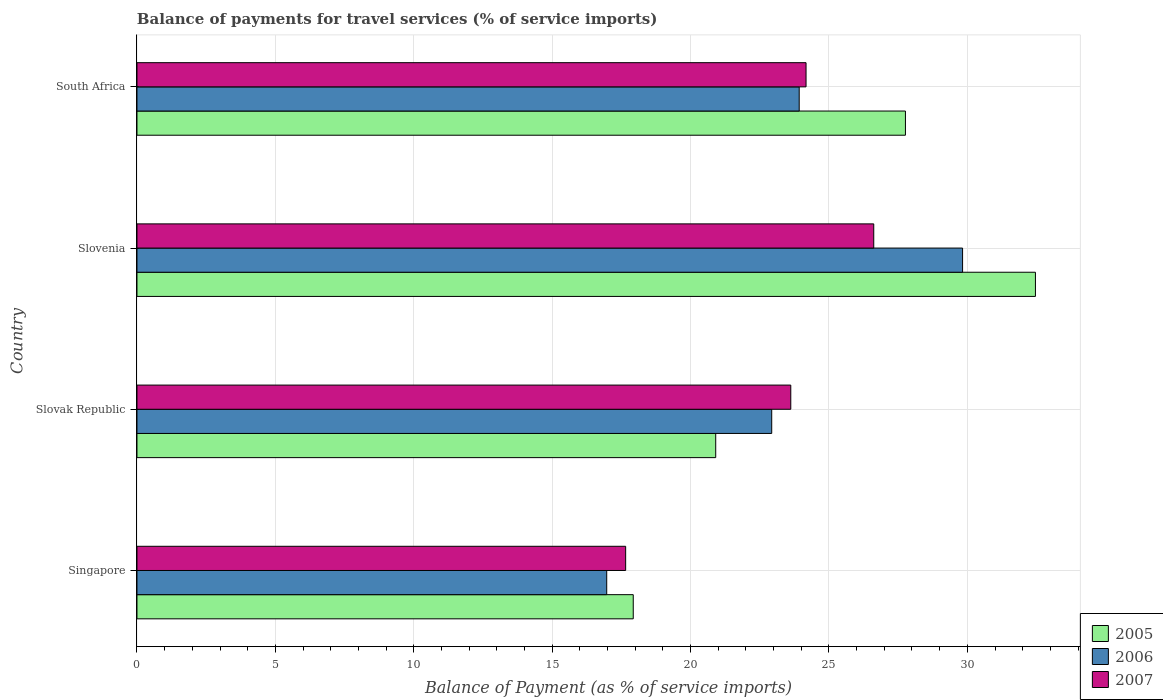How many different coloured bars are there?
Offer a terse response. 3. How many groups of bars are there?
Your answer should be very brief. 4. What is the label of the 4th group of bars from the top?
Your answer should be compact. Singapore. What is the balance of payments for travel services in 2007 in Slovak Republic?
Make the answer very short. 23.62. Across all countries, what is the maximum balance of payments for travel services in 2006?
Offer a terse response. 29.83. Across all countries, what is the minimum balance of payments for travel services in 2005?
Give a very brief answer. 17.93. In which country was the balance of payments for travel services in 2007 maximum?
Give a very brief answer. Slovenia. In which country was the balance of payments for travel services in 2005 minimum?
Ensure brevity in your answer.  Singapore. What is the total balance of payments for travel services in 2007 in the graph?
Your answer should be compact. 92.07. What is the difference between the balance of payments for travel services in 2006 in Singapore and that in Slovak Republic?
Give a very brief answer. -5.96. What is the difference between the balance of payments for travel services in 2007 in Slovak Republic and the balance of payments for travel services in 2005 in Slovenia?
Your answer should be compact. -8.84. What is the average balance of payments for travel services in 2007 per country?
Your answer should be compact. 23.02. What is the difference between the balance of payments for travel services in 2007 and balance of payments for travel services in 2005 in Slovak Republic?
Keep it short and to the point. 2.71. In how many countries, is the balance of payments for travel services in 2007 greater than 28 %?
Your answer should be very brief. 0. What is the ratio of the balance of payments for travel services in 2007 in Singapore to that in Slovak Republic?
Your response must be concise. 0.75. Is the balance of payments for travel services in 2005 in Slovak Republic less than that in Slovenia?
Give a very brief answer. Yes. Is the difference between the balance of payments for travel services in 2007 in Singapore and South Africa greater than the difference between the balance of payments for travel services in 2005 in Singapore and South Africa?
Ensure brevity in your answer.  Yes. What is the difference between the highest and the second highest balance of payments for travel services in 2005?
Keep it short and to the point. 4.7. What is the difference between the highest and the lowest balance of payments for travel services in 2007?
Make the answer very short. 8.96. Is the sum of the balance of payments for travel services in 2006 in Singapore and Slovak Republic greater than the maximum balance of payments for travel services in 2007 across all countries?
Make the answer very short. Yes. What does the 3rd bar from the bottom in Slovak Republic represents?
Give a very brief answer. 2007. Is it the case that in every country, the sum of the balance of payments for travel services in 2006 and balance of payments for travel services in 2007 is greater than the balance of payments for travel services in 2005?
Provide a succinct answer. Yes. What is the difference between two consecutive major ticks on the X-axis?
Ensure brevity in your answer.  5. Does the graph contain grids?
Offer a very short reply. Yes. Where does the legend appear in the graph?
Provide a succinct answer. Bottom right. How are the legend labels stacked?
Ensure brevity in your answer.  Vertical. What is the title of the graph?
Ensure brevity in your answer.  Balance of payments for travel services (% of service imports). What is the label or title of the X-axis?
Your response must be concise. Balance of Payment (as % of service imports). What is the label or title of the Y-axis?
Ensure brevity in your answer.  Country. What is the Balance of Payment (as % of service imports) in 2005 in Singapore?
Your answer should be very brief. 17.93. What is the Balance of Payment (as % of service imports) in 2006 in Singapore?
Your response must be concise. 16.97. What is the Balance of Payment (as % of service imports) in 2007 in Singapore?
Provide a short and direct response. 17.66. What is the Balance of Payment (as % of service imports) of 2005 in Slovak Republic?
Ensure brevity in your answer.  20.91. What is the Balance of Payment (as % of service imports) of 2006 in Slovak Republic?
Your answer should be compact. 22.93. What is the Balance of Payment (as % of service imports) in 2007 in Slovak Republic?
Your response must be concise. 23.62. What is the Balance of Payment (as % of service imports) of 2005 in Slovenia?
Offer a terse response. 32.46. What is the Balance of Payment (as % of service imports) of 2006 in Slovenia?
Provide a succinct answer. 29.83. What is the Balance of Payment (as % of service imports) in 2007 in Slovenia?
Make the answer very short. 26.62. What is the Balance of Payment (as % of service imports) of 2005 in South Africa?
Provide a short and direct response. 27.76. What is the Balance of Payment (as % of service imports) in 2006 in South Africa?
Keep it short and to the point. 23.93. What is the Balance of Payment (as % of service imports) in 2007 in South Africa?
Ensure brevity in your answer.  24.17. Across all countries, what is the maximum Balance of Payment (as % of service imports) of 2005?
Make the answer very short. 32.46. Across all countries, what is the maximum Balance of Payment (as % of service imports) of 2006?
Keep it short and to the point. 29.83. Across all countries, what is the maximum Balance of Payment (as % of service imports) in 2007?
Make the answer very short. 26.62. Across all countries, what is the minimum Balance of Payment (as % of service imports) in 2005?
Your response must be concise. 17.93. Across all countries, what is the minimum Balance of Payment (as % of service imports) of 2006?
Your answer should be compact. 16.97. Across all countries, what is the minimum Balance of Payment (as % of service imports) of 2007?
Make the answer very short. 17.66. What is the total Balance of Payment (as % of service imports) in 2005 in the graph?
Give a very brief answer. 99.06. What is the total Balance of Payment (as % of service imports) of 2006 in the graph?
Your answer should be very brief. 93.66. What is the total Balance of Payment (as % of service imports) of 2007 in the graph?
Your response must be concise. 92.07. What is the difference between the Balance of Payment (as % of service imports) of 2005 in Singapore and that in Slovak Republic?
Ensure brevity in your answer.  -2.98. What is the difference between the Balance of Payment (as % of service imports) of 2006 in Singapore and that in Slovak Republic?
Give a very brief answer. -5.96. What is the difference between the Balance of Payment (as % of service imports) of 2007 in Singapore and that in Slovak Republic?
Offer a very short reply. -5.97. What is the difference between the Balance of Payment (as % of service imports) of 2005 in Singapore and that in Slovenia?
Your answer should be compact. -14.53. What is the difference between the Balance of Payment (as % of service imports) in 2006 in Singapore and that in Slovenia?
Your answer should be compact. -12.86. What is the difference between the Balance of Payment (as % of service imports) of 2007 in Singapore and that in Slovenia?
Your answer should be very brief. -8.96. What is the difference between the Balance of Payment (as % of service imports) of 2005 in Singapore and that in South Africa?
Your response must be concise. -9.83. What is the difference between the Balance of Payment (as % of service imports) in 2006 in Singapore and that in South Africa?
Ensure brevity in your answer.  -6.95. What is the difference between the Balance of Payment (as % of service imports) of 2007 in Singapore and that in South Africa?
Keep it short and to the point. -6.52. What is the difference between the Balance of Payment (as % of service imports) of 2005 in Slovak Republic and that in Slovenia?
Your response must be concise. -11.55. What is the difference between the Balance of Payment (as % of service imports) of 2006 in Slovak Republic and that in Slovenia?
Provide a succinct answer. -6.9. What is the difference between the Balance of Payment (as % of service imports) in 2007 in Slovak Republic and that in Slovenia?
Your answer should be compact. -3. What is the difference between the Balance of Payment (as % of service imports) in 2005 in Slovak Republic and that in South Africa?
Provide a short and direct response. -6.85. What is the difference between the Balance of Payment (as % of service imports) in 2006 in Slovak Republic and that in South Africa?
Ensure brevity in your answer.  -0.99. What is the difference between the Balance of Payment (as % of service imports) in 2007 in Slovak Republic and that in South Africa?
Make the answer very short. -0.55. What is the difference between the Balance of Payment (as % of service imports) in 2005 in Slovenia and that in South Africa?
Keep it short and to the point. 4.7. What is the difference between the Balance of Payment (as % of service imports) of 2006 in Slovenia and that in South Africa?
Provide a short and direct response. 5.9. What is the difference between the Balance of Payment (as % of service imports) in 2007 in Slovenia and that in South Africa?
Give a very brief answer. 2.45. What is the difference between the Balance of Payment (as % of service imports) in 2005 in Singapore and the Balance of Payment (as % of service imports) in 2006 in Slovak Republic?
Provide a short and direct response. -5. What is the difference between the Balance of Payment (as % of service imports) in 2005 in Singapore and the Balance of Payment (as % of service imports) in 2007 in Slovak Republic?
Provide a succinct answer. -5.69. What is the difference between the Balance of Payment (as % of service imports) in 2006 in Singapore and the Balance of Payment (as % of service imports) in 2007 in Slovak Republic?
Keep it short and to the point. -6.65. What is the difference between the Balance of Payment (as % of service imports) in 2005 in Singapore and the Balance of Payment (as % of service imports) in 2006 in Slovenia?
Your response must be concise. -11.9. What is the difference between the Balance of Payment (as % of service imports) of 2005 in Singapore and the Balance of Payment (as % of service imports) of 2007 in Slovenia?
Offer a terse response. -8.69. What is the difference between the Balance of Payment (as % of service imports) in 2006 in Singapore and the Balance of Payment (as % of service imports) in 2007 in Slovenia?
Give a very brief answer. -9.65. What is the difference between the Balance of Payment (as % of service imports) of 2005 in Singapore and the Balance of Payment (as % of service imports) of 2006 in South Africa?
Your answer should be compact. -6. What is the difference between the Balance of Payment (as % of service imports) in 2005 in Singapore and the Balance of Payment (as % of service imports) in 2007 in South Africa?
Provide a succinct answer. -6.24. What is the difference between the Balance of Payment (as % of service imports) in 2006 in Singapore and the Balance of Payment (as % of service imports) in 2007 in South Africa?
Your answer should be compact. -7.2. What is the difference between the Balance of Payment (as % of service imports) in 2005 in Slovak Republic and the Balance of Payment (as % of service imports) in 2006 in Slovenia?
Give a very brief answer. -8.92. What is the difference between the Balance of Payment (as % of service imports) of 2005 in Slovak Republic and the Balance of Payment (as % of service imports) of 2007 in Slovenia?
Your answer should be very brief. -5.71. What is the difference between the Balance of Payment (as % of service imports) in 2006 in Slovak Republic and the Balance of Payment (as % of service imports) in 2007 in Slovenia?
Offer a very short reply. -3.69. What is the difference between the Balance of Payment (as % of service imports) of 2005 in Slovak Republic and the Balance of Payment (as % of service imports) of 2006 in South Africa?
Your response must be concise. -3.02. What is the difference between the Balance of Payment (as % of service imports) in 2005 in Slovak Republic and the Balance of Payment (as % of service imports) in 2007 in South Africa?
Provide a succinct answer. -3.26. What is the difference between the Balance of Payment (as % of service imports) in 2006 in Slovak Republic and the Balance of Payment (as % of service imports) in 2007 in South Africa?
Give a very brief answer. -1.24. What is the difference between the Balance of Payment (as % of service imports) of 2005 in Slovenia and the Balance of Payment (as % of service imports) of 2006 in South Africa?
Make the answer very short. 8.53. What is the difference between the Balance of Payment (as % of service imports) in 2005 in Slovenia and the Balance of Payment (as % of service imports) in 2007 in South Africa?
Your response must be concise. 8.29. What is the difference between the Balance of Payment (as % of service imports) in 2006 in Slovenia and the Balance of Payment (as % of service imports) in 2007 in South Africa?
Make the answer very short. 5.66. What is the average Balance of Payment (as % of service imports) in 2005 per country?
Provide a short and direct response. 24.77. What is the average Balance of Payment (as % of service imports) in 2006 per country?
Offer a terse response. 23.41. What is the average Balance of Payment (as % of service imports) in 2007 per country?
Your response must be concise. 23.02. What is the difference between the Balance of Payment (as % of service imports) in 2005 and Balance of Payment (as % of service imports) in 2006 in Singapore?
Your response must be concise. 0.96. What is the difference between the Balance of Payment (as % of service imports) of 2005 and Balance of Payment (as % of service imports) of 2007 in Singapore?
Provide a succinct answer. 0.27. What is the difference between the Balance of Payment (as % of service imports) in 2006 and Balance of Payment (as % of service imports) in 2007 in Singapore?
Provide a succinct answer. -0.68. What is the difference between the Balance of Payment (as % of service imports) in 2005 and Balance of Payment (as % of service imports) in 2006 in Slovak Republic?
Offer a terse response. -2.02. What is the difference between the Balance of Payment (as % of service imports) in 2005 and Balance of Payment (as % of service imports) in 2007 in Slovak Republic?
Give a very brief answer. -2.71. What is the difference between the Balance of Payment (as % of service imports) in 2006 and Balance of Payment (as % of service imports) in 2007 in Slovak Republic?
Offer a terse response. -0.69. What is the difference between the Balance of Payment (as % of service imports) in 2005 and Balance of Payment (as % of service imports) in 2006 in Slovenia?
Offer a very short reply. 2.63. What is the difference between the Balance of Payment (as % of service imports) in 2005 and Balance of Payment (as % of service imports) in 2007 in Slovenia?
Provide a short and direct response. 5.84. What is the difference between the Balance of Payment (as % of service imports) in 2006 and Balance of Payment (as % of service imports) in 2007 in Slovenia?
Provide a succinct answer. 3.21. What is the difference between the Balance of Payment (as % of service imports) of 2005 and Balance of Payment (as % of service imports) of 2006 in South Africa?
Offer a terse response. 3.84. What is the difference between the Balance of Payment (as % of service imports) in 2005 and Balance of Payment (as % of service imports) in 2007 in South Africa?
Your answer should be very brief. 3.59. What is the difference between the Balance of Payment (as % of service imports) of 2006 and Balance of Payment (as % of service imports) of 2007 in South Africa?
Keep it short and to the point. -0.25. What is the ratio of the Balance of Payment (as % of service imports) of 2005 in Singapore to that in Slovak Republic?
Provide a succinct answer. 0.86. What is the ratio of the Balance of Payment (as % of service imports) of 2006 in Singapore to that in Slovak Republic?
Provide a short and direct response. 0.74. What is the ratio of the Balance of Payment (as % of service imports) in 2007 in Singapore to that in Slovak Republic?
Offer a terse response. 0.75. What is the ratio of the Balance of Payment (as % of service imports) in 2005 in Singapore to that in Slovenia?
Offer a very short reply. 0.55. What is the ratio of the Balance of Payment (as % of service imports) in 2006 in Singapore to that in Slovenia?
Your answer should be very brief. 0.57. What is the ratio of the Balance of Payment (as % of service imports) in 2007 in Singapore to that in Slovenia?
Ensure brevity in your answer.  0.66. What is the ratio of the Balance of Payment (as % of service imports) in 2005 in Singapore to that in South Africa?
Give a very brief answer. 0.65. What is the ratio of the Balance of Payment (as % of service imports) in 2006 in Singapore to that in South Africa?
Provide a succinct answer. 0.71. What is the ratio of the Balance of Payment (as % of service imports) in 2007 in Singapore to that in South Africa?
Provide a succinct answer. 0.73. What is the ratio of the Balance of Payment (as % of service imports) in 2005 in Slovak Republic to that in Slovenia?
Keep it short and to the point. 0.64. What is the ratio of the Balance of Payment (as % of service imports) of 2006 in Slovak Republic to that in Slovenia?
Provide a succinct answer. 0.77. What is the ratio of the Balance of Payment (as % of service imports) in 2007 in Slovak Republic to that in Slovenia?
Give a very brief answer. 0.89. What is the ratio of the Balance of Payment (as % of service imports) in 2005 in Slovak Republic to that in South Africa?
Provide a succinct answer. 0.75. What is the ratio of the Balance of Payment (as % of service imports) of 2006 in Slovak Republic to that in South Africa?
Make the answer very short. 0.96. What is the ratio of the Balance of Payment (as % of service imports) in 2007 in Slovak Republic to that in South Africa?
Make the answer very short. 0.98. What is the ratio of the Balance of Payment (as % of service imports) in 2005 in Slovenia to that in South Africa?
Give a very brief answer. 1.17. What is the ratio of the Balance of Payment (as % of service imports) in 2006 in Slovenia to that in South Africa?
Your response must be concise. 1.25. What is the ratio of the Balance of Payment (as % of service imports) of 2007 in Slovenia to that in South Africa?
Give a very brief answer. 1.1. What is the difference between the highest and the second highest Balance of Payment (as % of service imports) in 2005?
Your answer should be very brief. 4.7. What is the difference between the highest and the second highest Balance of Payment (as % of service imports) of 2006?
Your answer should be very brief. 5.9. What is the difference between the highest and the second highest Balance of Payment (as % of service imports) in 2007?
Make the answer very short. 2.45. What is the difference between the highest and the lowest Balance of Payment (as % of service imports) of 2005?
Keep it short and to the point. 14.53. What is the difference between the highest and the lowest Balance of Payment (as % of service imports) of 2006?
Your answer should be compact. 12.86. What is the difference between the highest and the lowest Balance of Payment (as % of service imports) of 2007?
Provide a short and direct response. 8.96. 